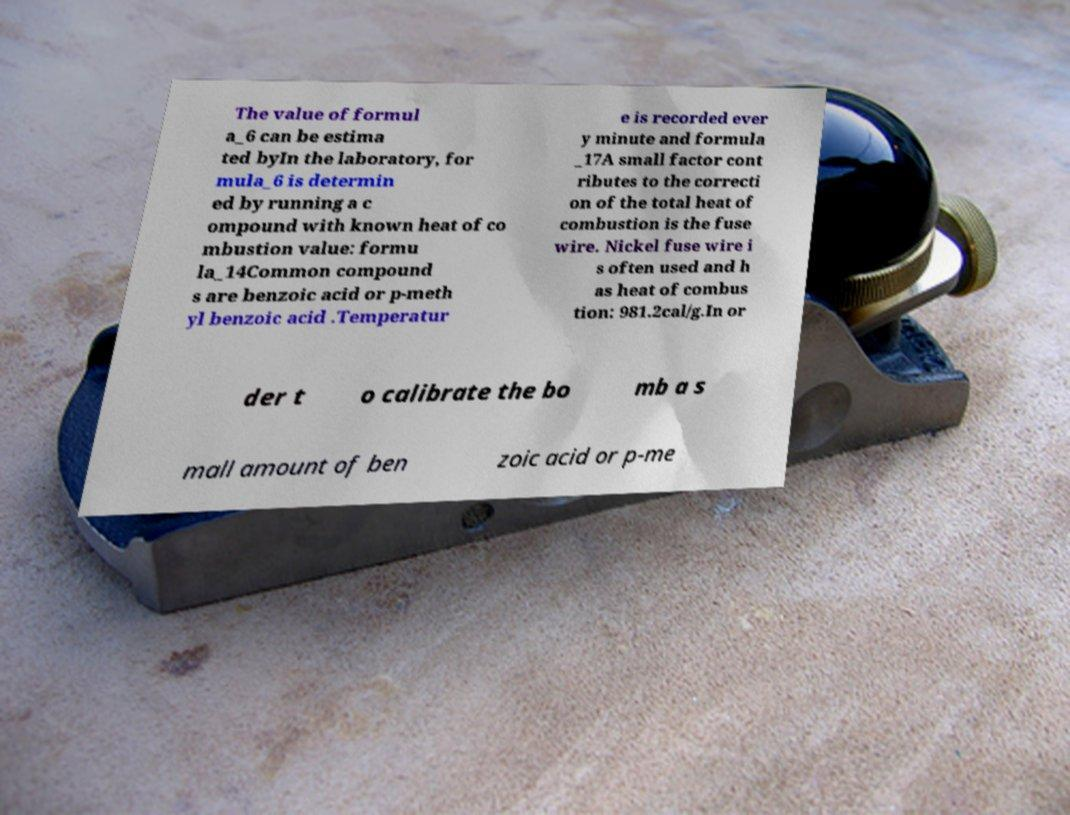I need the written content from this picture converted into text. Can you do that? The value of formul a_6 can be estima ted byIn the laboratory, for mula_6 is determin ed by running a c ompound with known heat of co mbustion value: formu la_14Common compound s are benzoic acid or p-meth yl benzoic acid .Temperatur e is recorded ever y minute and formula _17A small factor cont ributes to the correcti on of the total heat of combustion is the fuse wire. Nickel fuse wire i s often used and h as heat of combus tion: 981.2cal/g.In or der t o calibrate the bo mb a s mall amount of ben zoic acid or p-me 